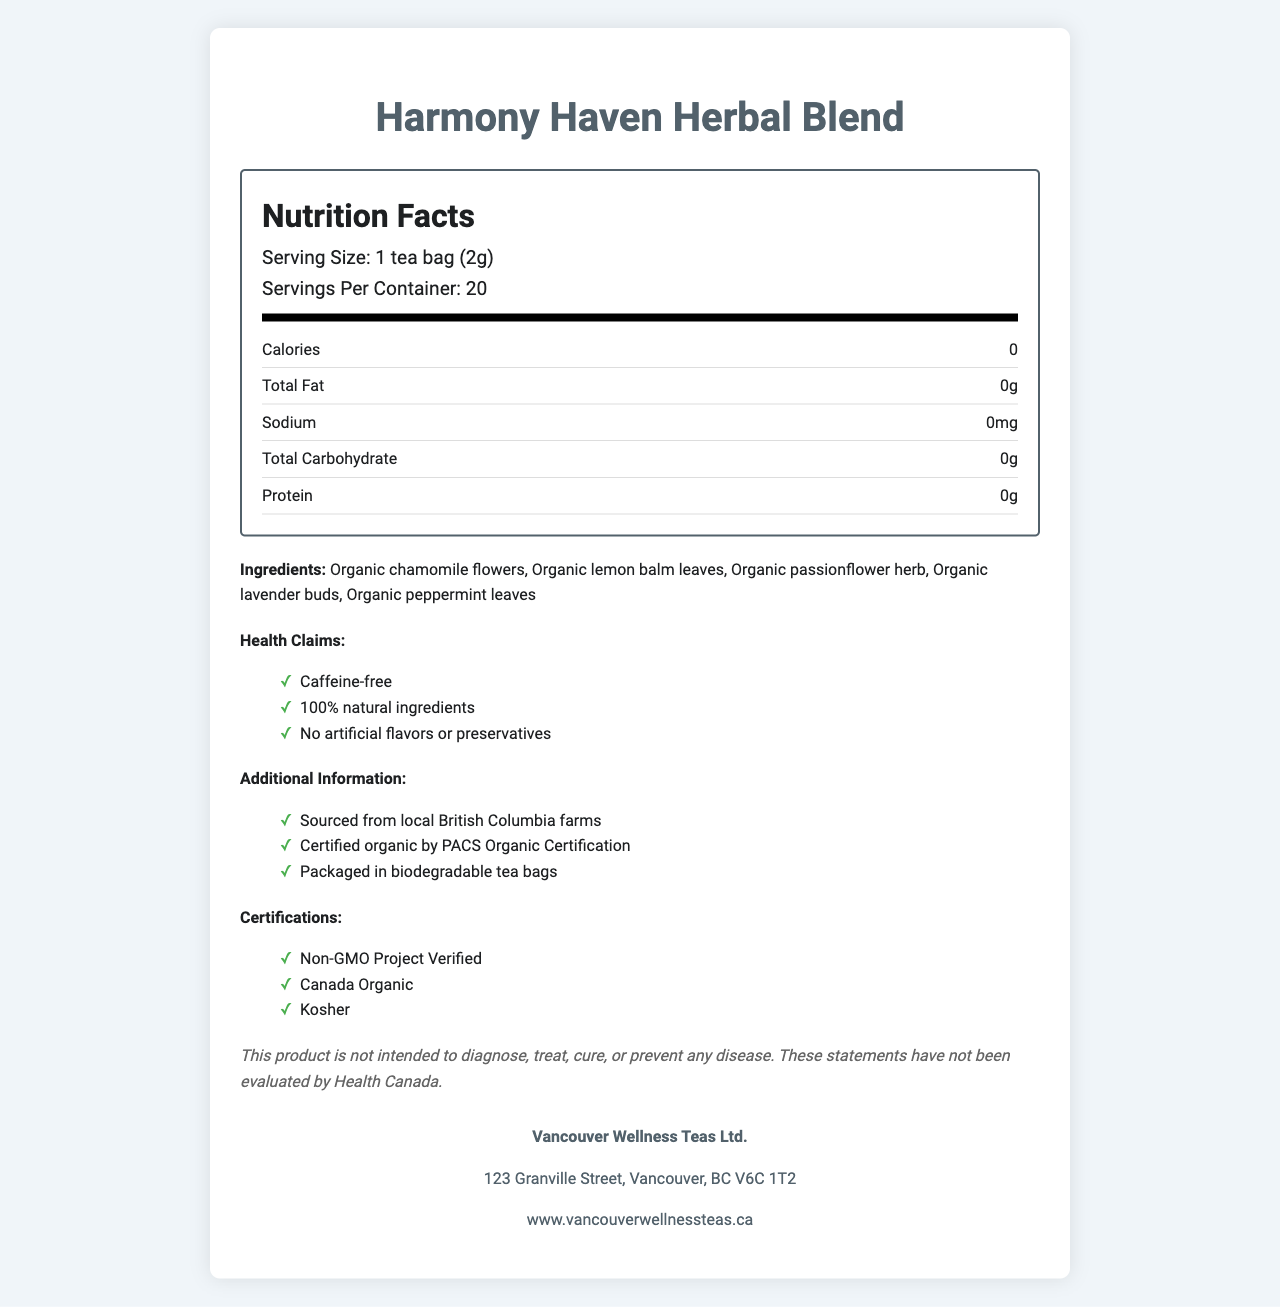what is the serving size? The serving size is listed in the document as "1 tea bag (2g)".
Answer: 1 tea bag (2g) how many servings are there per container? The document mentions "Servings Per Container: 20".
Answer: 20 what is the calorie count per serving? The calorie count per serving is mentioned as "Calories: 0".
Answer: 0 what are the main ingredients in this herbal blend? The ingredients listed under "Ingredients" include: Organic chamomile flowers, Organic lemon balm leaves, Organic passionflower herb, Organic lavender buds, Organic peppermint leaves.
Answer: Organic chamomile flowers, Organic lemon balm leaves, Organic passionflower herb, Organic lavender buds, Organic peppermint leaves where is the manufacturer located? The manufacturer's address is given as "123 Granville Street, Vancouver, BC V6C 1T2".
Answer: 123 Granville Street, Vancouver, BC V6C 1T2 which of the following is a health claim of this herbal tea?  
A. Contains caffeine  
B. Sugar-free  
C. 100% natural ingredients The health claims listed in the document are "Caffeine-free", "100% natural ingredients", and "No artificial flavors or preservatives". Among the options, "100% natural ingredients" is a correct health claim.
Answer: C what certifications does Harmony Haven Herbal Blend have?  
I. Non-GMO Project Verified  
II. FDA Approved  
III. Canada Organic  
IV. Kosher The certifications listed in the document are "Non-GMO Project Verified", "Canada Organic", and "Kosher".
Answer: I, III, IV Is this tea caffeine-free? One of the health claims listed is "Caffeine-free".
Answer: Yes summarize the nutritional characteristics of this product. The blend is promoted primarily for its natural ingredients and health benefits, having no calories, fats, sodium, carbohydrates, or proteins.
Answer: Harmony Haven Herbal Blend is a caffeine-free, herbal tea blend with zero calories, no fats, sodium, carbohydrates, or proteins. It is also 100% natural, containing organic ingredients and no artificial flavors or preservatives. what is the procedure for preparing this tea? The preparation instructions mention to "Steep in hot water for 5-7 minutes".
Answer: Steep in hot water for 5-7 minutes does this product contain any artificial flavors or preservatives? One of the health claims is "No artificial flavors or preservatives".
Answer: No what is the total fat content per serving? The document lists "Total Fat: 0g".
Answer: 0g are there any allergens associated with this product? The allergy information mentions that it is "Processed in a facility that also handles nuts and soy".
Answer: Yes, Processed in a facility that also handles nuts and soy can this product diagnose or cure diseases? The disclaimer notes that "This product is not intended to diagnose, treat, cure, or prevent any disease."
Answer: No where are the ingredients sourced from? The additional information states "Sourced from local British Columbia farms".
Answer: Local British Columbia farms is this product certified organic? The additional information mentions it is "Certified organic by PACS Organic Certification."
Answer: Yes what type of packaging is used for this tea? The additional information states "Packaged in biodegradable tea bags."
Answer: Biodegradable tea bags what is the nutritional value of proteins in this tea? The document lists "Protein: 0g".
Answer: 0g can the precise caffeine content be determined from this document? The document mentions that the tea is caffeine-free, but does not provide specific measurements or detailed content analysis.
Answer: Not enough information is this product non-GMO? The document lists the certification "Non-GMO Project Verified".
Answer: Yes 